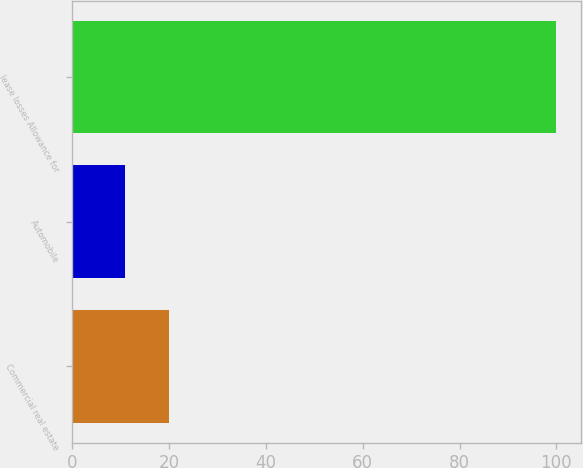Convert chart. <chart><loc_0><loc_0><loc_500><loc_500><bar_chart><fcel>Commercial real estate<fcel>Automobile<fcel>lease losses Allowance for<nl><fcel>19.9<fcel>11<fcel>100<nl></chart> 